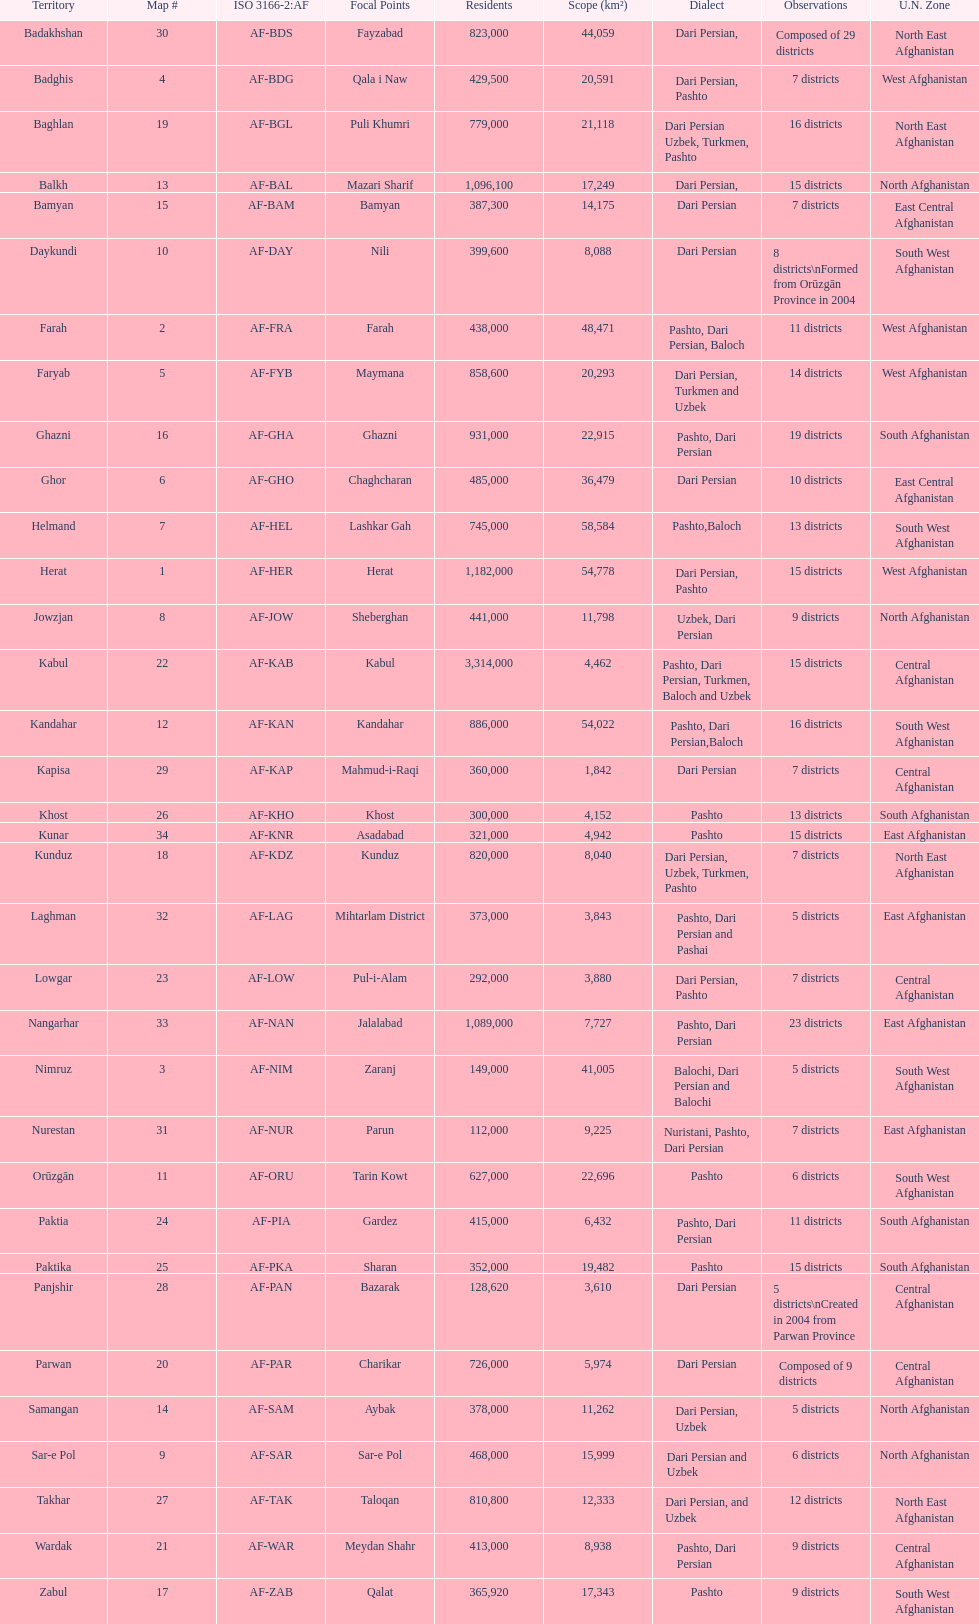Which province has the most districts? Badakhshan. 